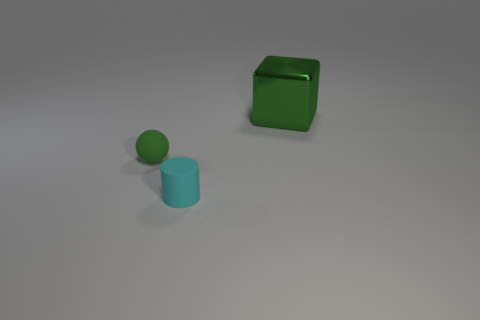What number of small spheres are the same color as the big shiny object?
Give a very brief answer. 1. What is the cyan cylinder made of?
Ensure brevity in your answer.  Rubber. Is there anything else that is made of the same material as the large green cube?
Ensure brevity in your answer.  No. Does the ball have the same color as the large object?
Ensure brevity in your answer.  Yes. What is the size of the cyan cylinder?
Offer a very short reply. Small. Is the cyan cylinder made of the same material as the big green cube?
Offer a very short reply. No. How many cubes are either blue rubber objects or green shiny things?
Provide a succinct answer. 1. What color is the small rubber thing that is to the left of the object that is in front of the green ball?
Offer a terse response. Green. There is a sphere that is the same color as the big thing; what is its size?
Provide a succinct answer. Small. There is a tiny matte object that is to the right of the rubber object that is behind the tiny cyan matte thing; what number of tiny green spheres are in front of it?
Your answer should be compact. 0. 